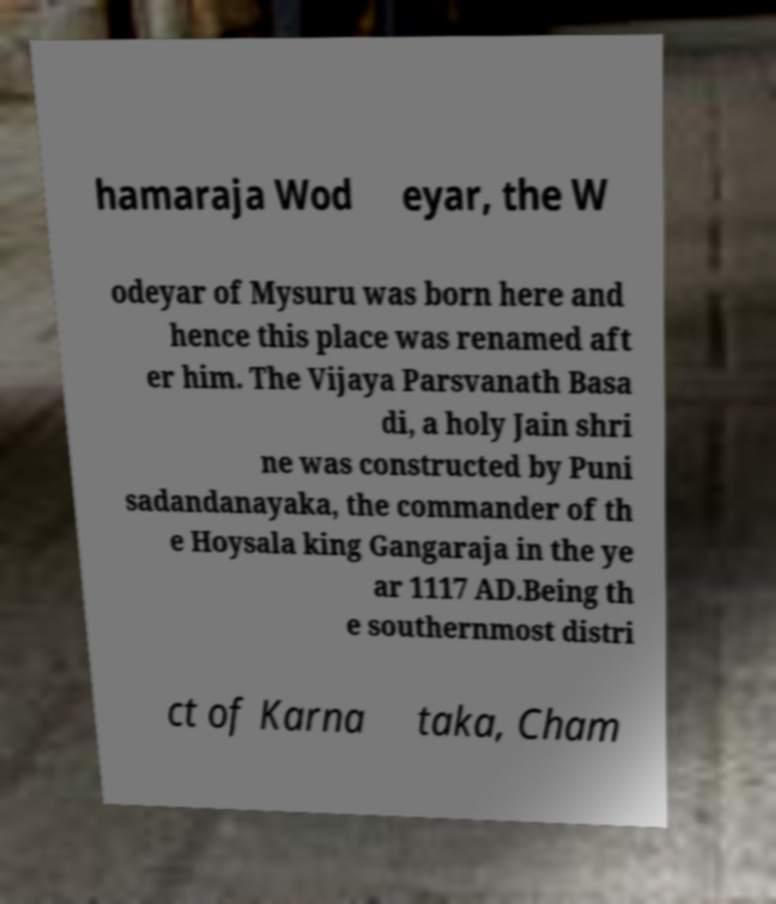Please identify and transcribe the text found in this image. hamaraja Wod eyar, the W odeyar of Mysuru was born here and hence this place was renamed aft er him. The Vijaya Parsvanath Basa di, a holy Jain shri ne was constructed by Puni sadandanayaka, the commander of th e Hoysala king Gangaraja in the ye ar 1117 AD.Being th e southernmost distri ct of Karna taka, Cham 